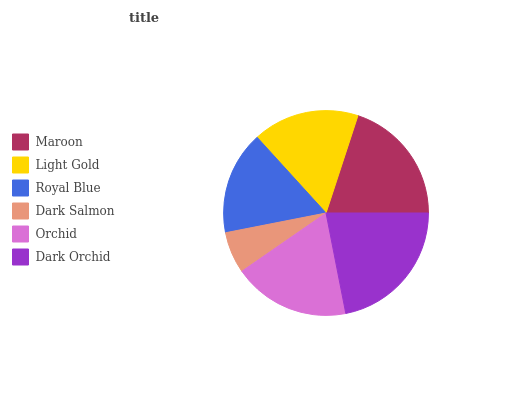Is Dark Salmon the minimum?
Answer yes or no. Yes. Is Dark Orchid the maximum?
Answer yes or no. Yes. Is Light Gold the minimum?
Answer yes or no. No. Is Light Gold the maximum?
Answer yes or no. No. Is Maroon greater than Light Gold?
Answer yes or no. Yes. Is Light Gold less than Maroon?
Answer yes or no. Yes. Is Light Gold greater than Maroon?
Answer yes or no. No. Is Maroon less than Light Gold?
Answer yes or no. No. Is Orchid the high median?
Answer yes or no. Yes. Is Light Gold the low median?
Answer yes or no. Yes. Is Dark Salmon the high median?
Answer yes or no. No. Is Maroon the low median?
Answer yes or no. No. 